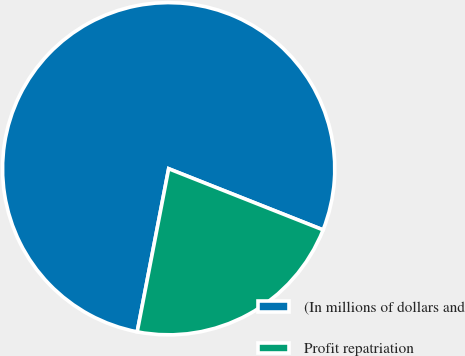Convert chart to OTSL. <chart><loc_0><loc_0><loc_500><loc_500><pie_chart><fcel>(In millions of dollars and<fcel>Profit repatriation<nl><fcel>77.97%<fcel>22.03%<nl></chart> 